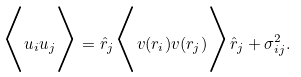Convert formula to latex. <formula><loc_0><loc_0><loc_500><loc_500>\Big < u _ { i } u _ { j } \Big > = \hat { r } _ { j } \Big < { v } ( { r } _ { i } ) { v } ( { r } _ { j } ) \Big > \hat { r } _ { j } + \sigma { ^ { 2 } _ { i j } } .</formula> 